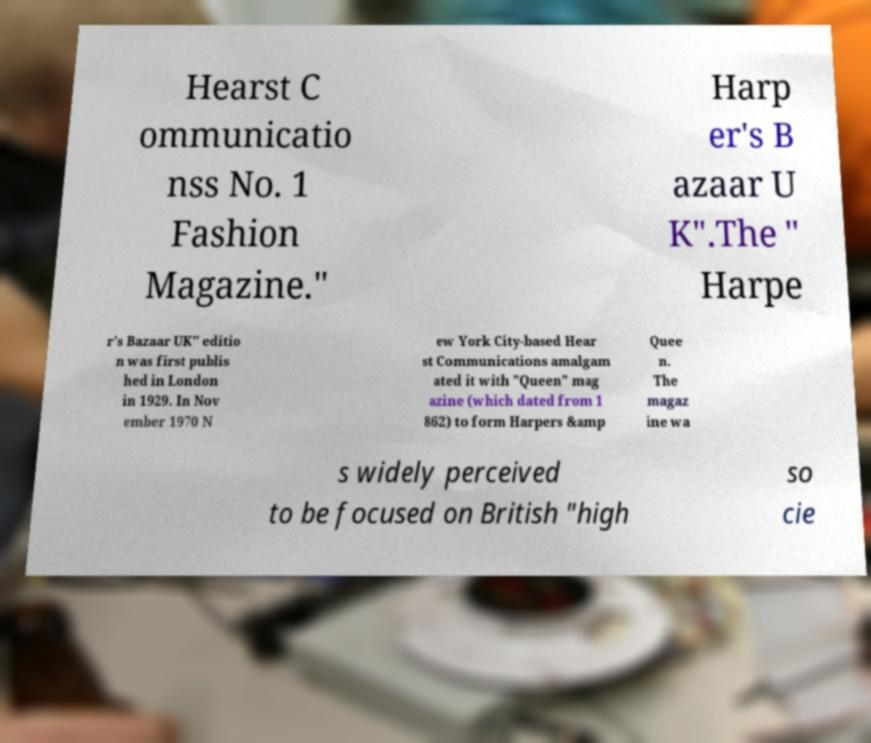Can you read and provide the text displayed in the image?This photo seems to have some interesting text. Can you extract and type it out for me? Hearst C ommunicatio nss No. 1 Fashion Magazine." Harp er's B azaar U K".The " Harpe r's Bazaar UK" editio n was first publis hed in London in 1929. In Nov ember 1970 N ew York City-based Hear st Communications amalgam ated it with "Queen" mag azine (which dated from 1 862) to form Harpers &amp Quee n. The magaz ine wa s widely perceived to be focused on British "high so cie 